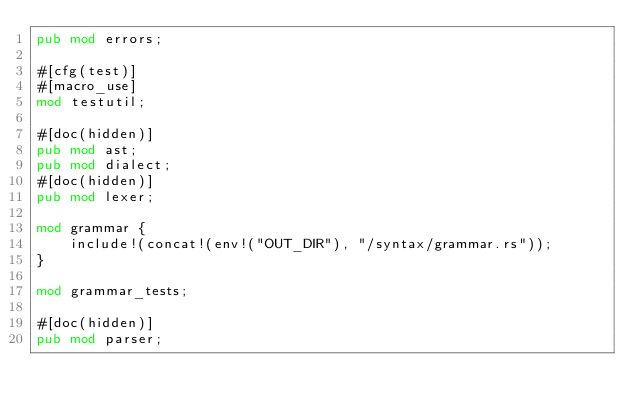<code> <loc_0><loc_0><loc_500><loc_500><_Rust_>pub mod errors;

#[cfg(test)]
#[macro_use]
mod testutil;

#[doc(hidden)]
pub mod ast;
pub mod dialect;
#[doc(hidden)]
pub mod lexer;

mod grammar {
    include!(concat!(env!("OUT_DIR"), "/syntax/grammar.rs"));
}

mod grammar_tests;

#[doc(hidden)]
pub mod parser;
</code> 